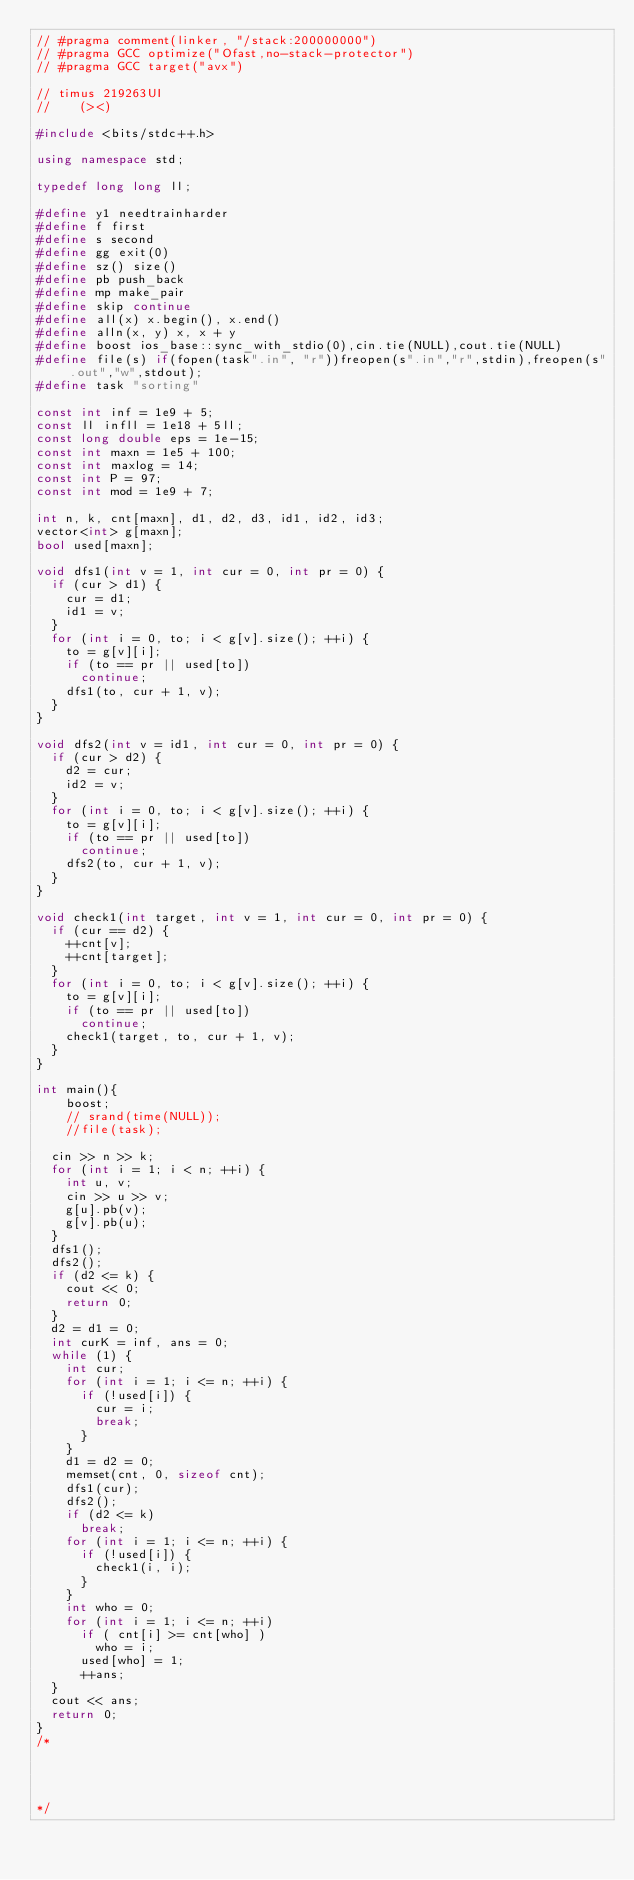Convert code to text. <code><loc_0><loc_0><loc_500><loc_500><_C++_>// #pragma comment(linker, "/stack:200000000")
// #pragma GCC optimize("Ofast,no-stack-protector")
// #pragma GCC target("avx")

// timus 219263UI
//    (><)

#include <bits/stdc++.h>

using namespace std;

typedef long long ll;

#define y1 needtrainharder
#define f first
#define s second
#define gg exit(0)
#define sz() size()
#define pb push_back
#define mp make_pair
#define skip continue
#define all(x) x.begin(), x.end()
#define alln(x, y) x, x + y
#define boost ios_base::sync_with_stdio(0),cin.tie(NULL),cout.tie(NULL)
#define file(s) if(fopen(task".in", "r"))freopen(s".in","r",stdin),freopen(s".out","w",stdout);
#define task "sorting"

const int inf = 1e9 + 5;  
const ll infll = 1e18 + 5ll;  
const long double eps = 1e-15;
const int maxn = 1e5 + 100;
const int maxlog = 14;
const int P = 97;
const int mod = 1e9 + 7;
                   
int n, k, cnt[maxn], d1, d2, d3, id1, id2, id3;
vector<int> g[maxn];
bool used[maxn];
 
void dfs1(int v = 1, int cur = 0, int pr = 0) {
	if (cur > d1) {
		cur = d1;
		id1 = v;
	}
	for (int i = 0, to; i < g[v].size(); ++i) {
		to = g[v][i];
		if (to == pr || used[to])
			continue;
		dfs1(to, cur + 1, v);
	}
}
 
void dfs2(int v = id1, int cur = 0, int pr = 0) {
	if (cur > d2) {
		d2 = cur;
		id2 = v;
	}
	for (int i = 0, to; i < g[v].size(); ++i) {
		to = g[v][i];
		if (to == pr || used[to])
			continue;
		dfs2(to, cur + 1, v);
	}
}
 
void check1(int target, int v = 1, int cur = 0, int pr = 0) {
	if (cur == d2) {
		++cnt[v];
		++cnt[target];
	}
	for (int i = 0, to; i < g[v].size(); ++i) { 
		to = g[v][i];
		if (to == pr || used[to])
			continue;
		check1(target, to, cur + 1, v);
	}
}
 
int main(){
  	boost; 
  	// srand(time(NULL));
  	//file(task);  

	cin >> n >> k;
	for (int i = 1; i < n; ++i) {
		int u, v;
		cin >> u >> v;
		g[u].pb(v);
		g[v].pb(u);
	}
	dfs1();
	dfs2();
	if (d2 <= k) {	
		cout << 0;
		return 0;
	}
	d2 = d1 = 0;
	int curK = inf, ans = 0;    
	while (1) {
		int cur;
		for (int i = 1; i <= n; ++i) {
			if (!used[i]) {
				cur = i;
				break;	
			}
		}
		d1 = d2 = 0;
		memset(cnt, 0, sizeof cnt);
		dfs1(cur);
		dfs2();
		if (d2 <= k)
			break;
		for (int i = 1; i <= n; ++i) {
		 	if (!used[i]) {
		 	 	check1(i, i);	
		 	}
		}
		int who = 0;
		for (int i = 1; i <= n; ++i)
			if ( cnt[i] >= cnt[who] )
				who = i;
	  	used[who] = 1;
	  	++ans;
	}
	cout << ans;       
	return 0;
}                
/*




*/</code> 